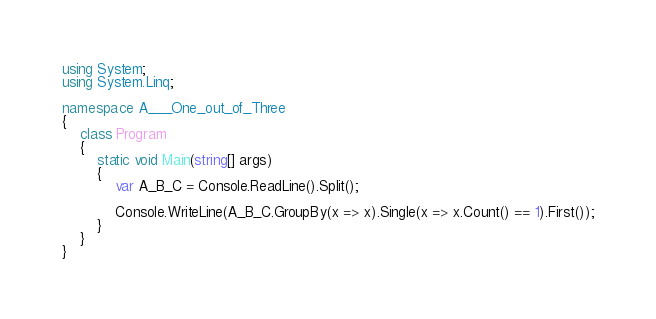<code> <loc_0><loc_0><loc_500><loc_500><_C#_>using System;
using System.Linq;

namespace A___One_out_of_Three
{
    class Program
    {
        static void Main(string[] args)
        {
            var A_B_C = Console.ReadLine().Split();

            Console.WriteLine(A_B_C.GroupBy(x => x).Single(x => x.Count() == 1).First());
        }
    }
}
</code> 